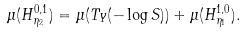<formula> <loc_0><loc_0><loc_500><loc_500>\mu ( H ^ { 0 , 1 } _ { \eta _ { 2 } } ) = \mu ( T _ { Y } ( - \log S ) ) + \mu ( H ^ { 1 , 0 } _ { \eta _ { 1 } } ) .</formula> 